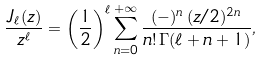<formula> <loc_0><loc_0><loc_500><loc_500>\frac { J _ { \ell } ( z ) } { z ^ { \ell } } = \left ( \frac { 1 } { 2 } \right ) ^ { \ell } \sum _ { n = 0 } ^ { + \infty } \frac { ( - ) ^ { n } \, ( z / 2 ) ^ { 2 n } } { n ! \, \Gamma ( \ell + n + 1 ) } ,</formula> 